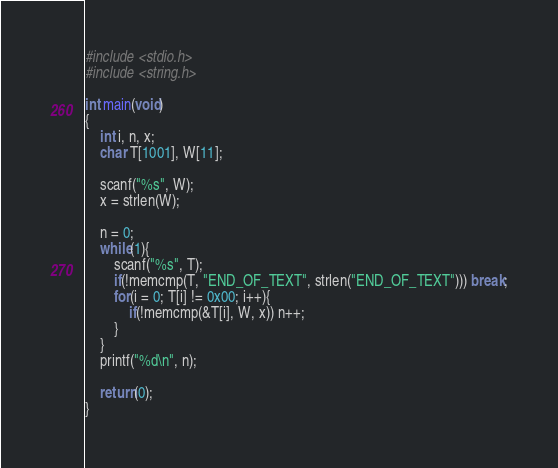<code> <loc_0><loc_0><loc_500><loc_500><_C_>#include <stdio.h>
#include <string.h>

int main(void)
{
	int i, n, x;
	char T[1001], W[11];
	
	scanf("%s", W);
	x = strlen(W);
	
	n = 0;
	while(1){
		scanf("%s", T);
		if(!memcmp(T, "END_OF_TEXT", strlen("END_OF_TEXT"))) break;
		for(i = 0; T[i] != 0x00; i++){
			if(!memcmp(&T[i], W, x)) n++;
		}
	}
	printf("%d\n", n);
	
	return(0);
}

</code> 